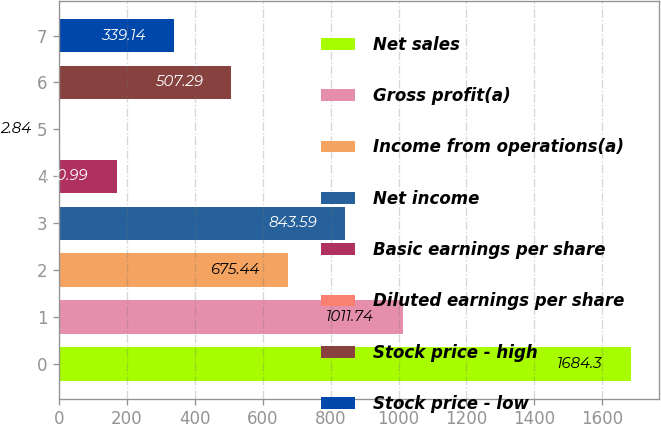Convert chart. <chart><loc_0><loc_0><loc_500><loc_500><bar_chart><fcel>Net sales<fcel>Gross profit(a)<fcel>Income from operations(a)<fcel>Net income<fcel>Basic earnings per share<fcel>Diluted earnings per share<fcel>Stock price - high<fcel>Stock price - low<nl><fcel>1684.3<fcel>1011.74<fcel>675.44<fcel>843.59<fcel>170.99<fcel>2.84<fcel>507.29<fcel>339.14<nl></chart> 